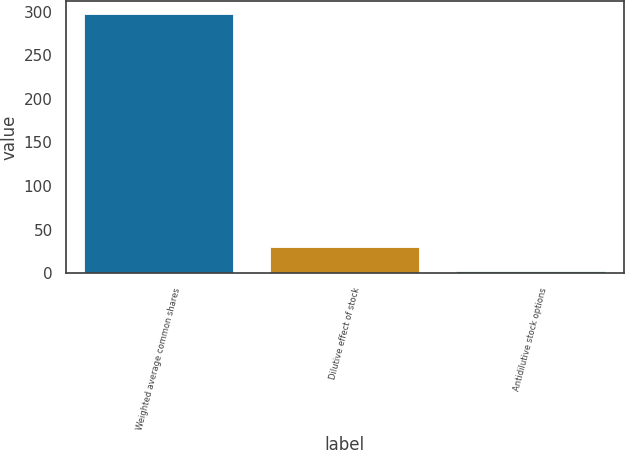Convert chart. <chart><loc_0><loc_0><loc_500><loc_500><bar_chart><fcel>Weighted average common shares<fcel>Dilutive effect of stock<fcel>Antidilutive stock options<nl><fcel>297.46<fcel>29.66<fcel>2.4<nl></chart> 